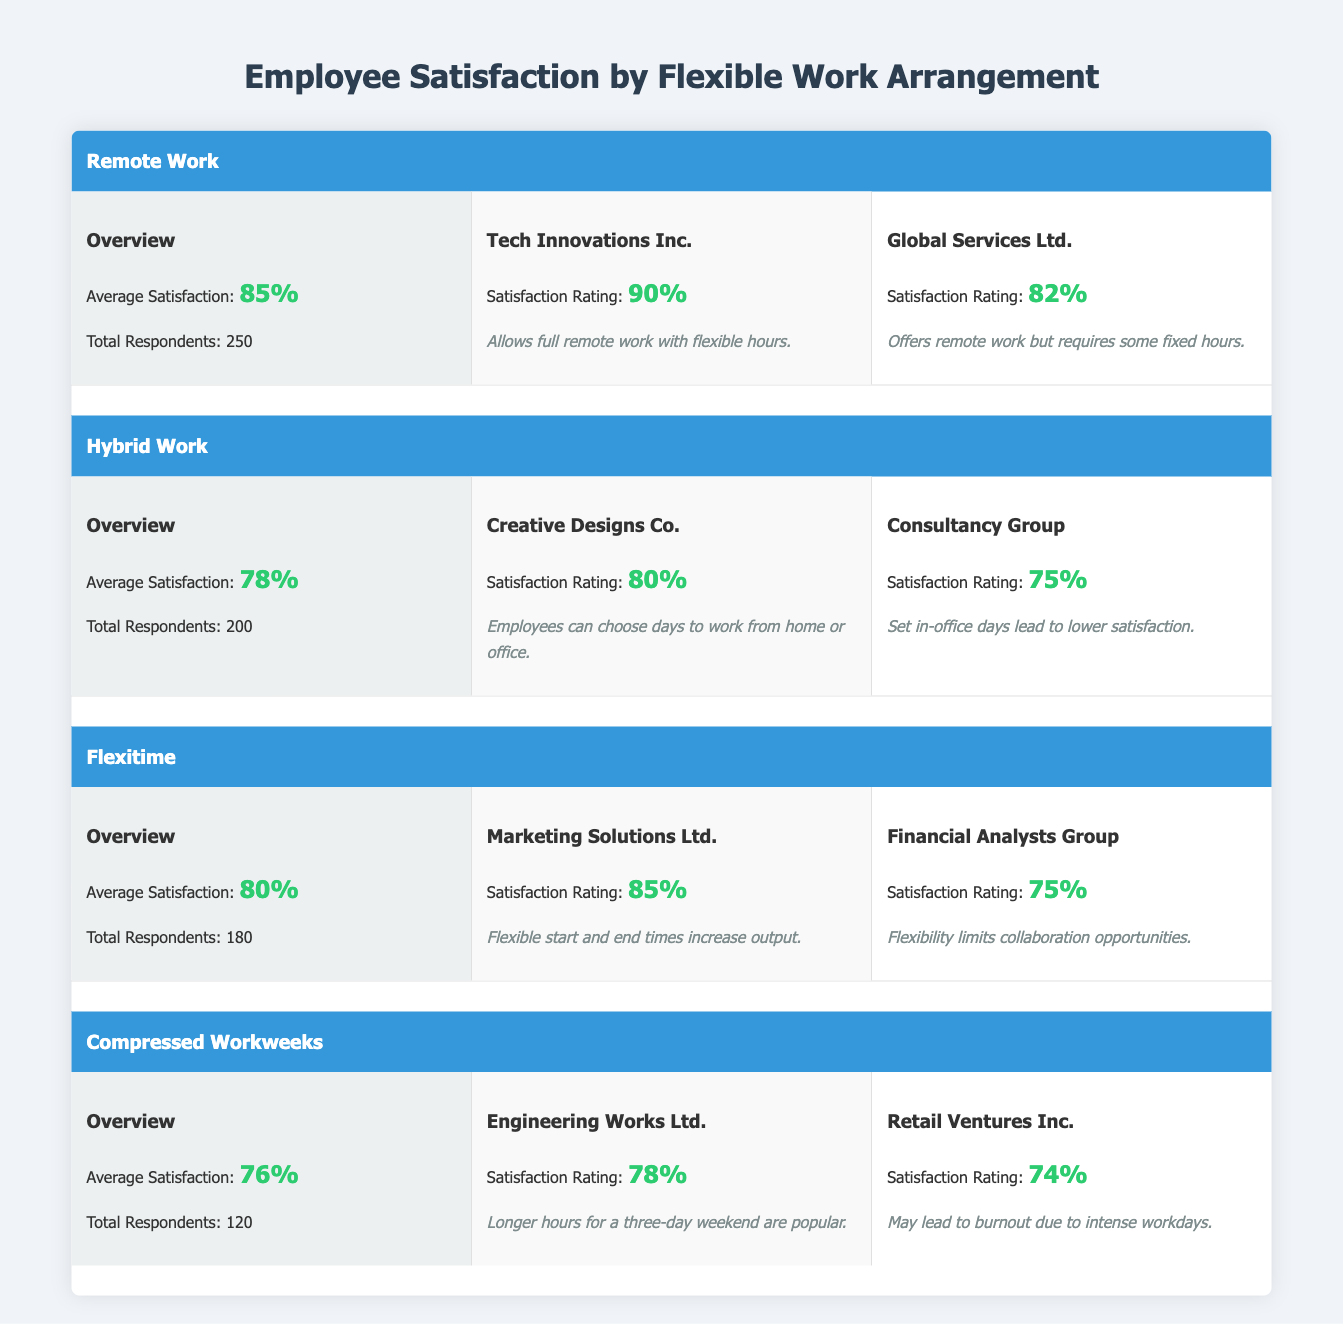What is the average satisfaction rating for Remote Work arrangements? The table shows that the average satisfaction for Remote Work is displayed in the overview section under "Remote". It states the Average Satisfaction is 85%.
Answer: 85% Which company has the highest satisfaction rating under the Hybrid Work category? In the Hybrid Work section, we can see the satisfaction ratings for "Creative Designs Co." is 80% and "Consultancy Group" is 75%. Since 80% is higher, "Creative Designs Co." has the highest rating.
Answer: Creative Designs Co Is the average satisfaction rating for Compressed Workweeks higher than that for Flexitime? The average satisfaction for Compressed Workweeks is 76% and for Flexitime, it is 80%. Since 76% is not higher than 80%, the statement is false.
Answer: No How many total respondents participated in the survey for Flexitime? The overview for Flexitime specifically states that the Total Respondents is 180, which is directly mentioned.
Answer: 180 What is the difference in average satisfaction between Remote and Hybrid work arrangements? The average satisfaction for Remote work is 85% and for Hybrid work is 78%. Therefore, the difference is 85% - 78% = 7%.
Answer: 7% Which work arrangement type has the lowest overall average satisfaction rating? Looking at the Overview sections, Remote has 85%, Hybrid has 78%, Flexitime has 80%, and Compressed Workweeks has 76%. The lowest is 76% for Compressed Workweeks.
Answer: Compressed Workweeks Which company has a comment indicating flexibility to work from both home and office? Only "Creative Designs Co." from the Hybrid category mentions that employees can choose days to work from home or office.
Answer: Creative Designs Co Is there a company in the Flexitime category that mentions limitations on collaboration? The "Financial Analysts Group" in the Flexitime category comments that flexibility limits collaboration opportunities, confirming the statement is true.
Answer: Yes 